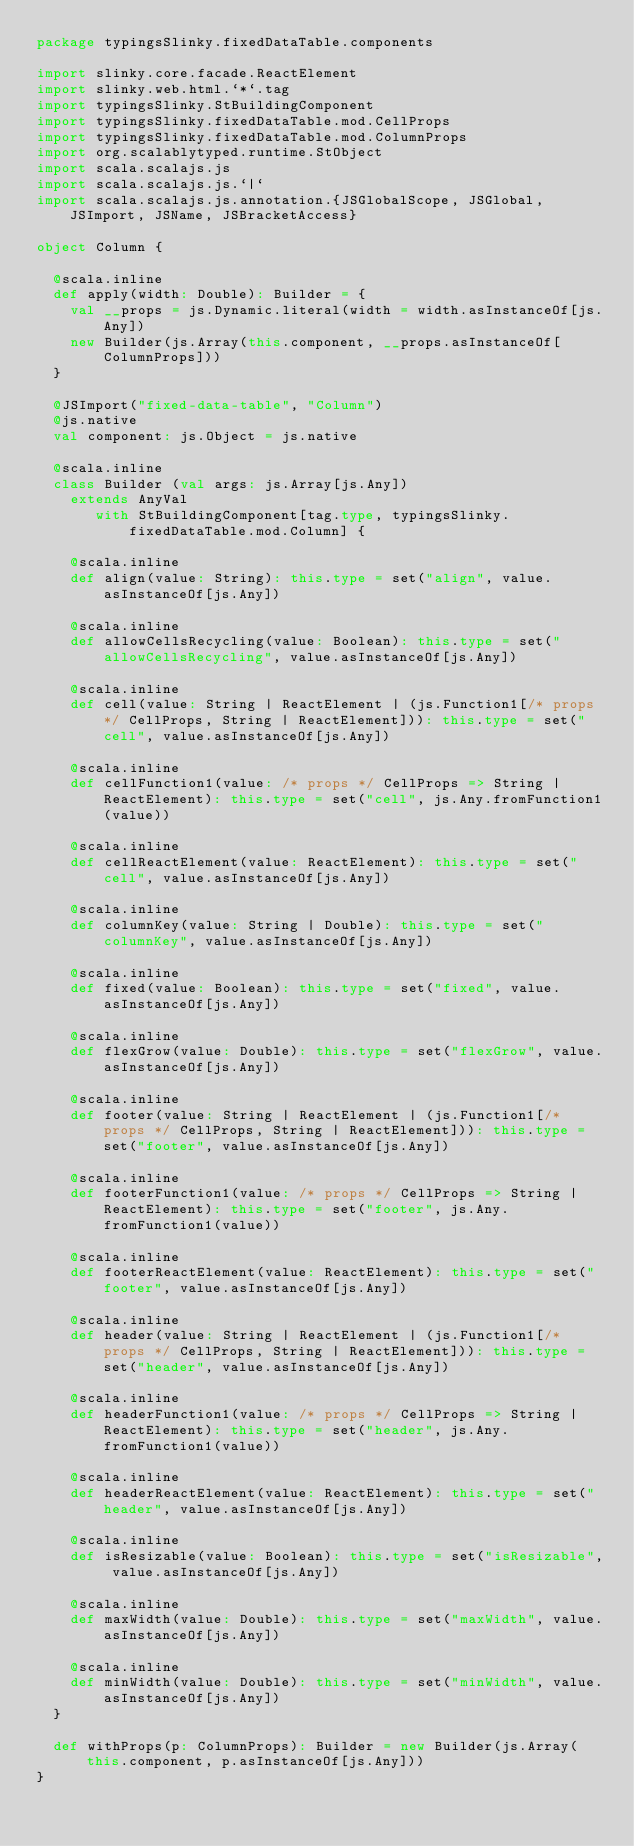<code> <loc_0><loc_0><loc_500><loc_500><_Scala_>package typingsSlinky.fixedDataTable.components

import slinky.core.facade.ReactElement
import slinky.web.html.`*`.tag
import typingsSlinky.StBuildingComponent
import typingsSlinky.fixedDataTable.mod.CellProps
import typingsSlinky.fixedDataTable.mod.ColumnProps
import org.scalablytyped.runtime.StObject
import scala.scalajs.js
import scala.scalajs.js.`|`
import scala.scalajs.js.annotation.{JSGlobalScope, JSGlobal, JSImport, JSName, JSBracketAccess}

object Column {
  
  @scala.inline
  def apply(width: Double): Builder = {
    val __props = js.Dynamic.literal(width = width.asInstanceOf[js.Any])
    new Builder(js.Array(this.component, __props.asInstanceOf[ColumnProps]))
  }
  
  @JSImport("fixed-data-table", "Column")
  @js.native
  val component: js.Object = js.native
  
  @scala.inline
  class Builder (val args: js.Array[js.Any])
    extends AnyVal
       with StBuildingComponent[tag.type, typingsSlinky.fixedDataTable.mod.Column] {
    
    @scala.inline
    def align(value: String): this.type = set("align", value.asInstanceOf[js.Any])
    
    @scala.inline
    def allowCellsRecycling(value: Boolean): this.type = set("allowCellsRecycling", value.asInstanceOf[js.Any])
    
    @scala.inline
    def cell(value: String | ReactElement | (js.Function1[/* props */ CellProps, String | ReactElement])): this.type = set("cell", value.asInstanceOf[js.Any])
    
    @scala.inline
    def cellFunction1(value: /* props */ CellProps => String | ReactElement): this.type = set("cell", js.Any.fromFunction1(value))
    
    @scala.inline
    def cellReactElement(value: ReactElement): this.type = set("cell", value.asInstanceOf[js.Any])
    
    @scala.inline
    def columnKey(value: String | Double): this.type = set("columnKey", value.asInstanceOf[js.Any])
    
    @scala.inline
    def fixed(value: Boolean): this.type = set("fixed", value.asInstanceOf[js.Any])
    
    @scala.inline
    def flexGrow(value: Double): this.type = set("flexGrow", value.asInstanceOf[js.Any])
    
    @scala.inline
    def footer(value: String | ReactElement | (js.Function1[/* props */ CellProps, String | ReactElement])): this.type = set("footer", value.asInstanceOf[js.Any])
    
    @scala.inline
    def footerFunction1(value: /* props */ CellProps => String | ReactElement): this.type = set("footer", js.Any.fromFunction1(value))
    
    @scala.inline
    def footerReactElement(value: ReactElement): this.type = set("footer", value.asInstanceOf[js.Any])
    
    @scala.inline
    def header(value: String | ReactElement | (js.Function1[/* props */ CellProps, String | ReactElement])): this.type = set("header", value.asInstanceOf[js.Any])
    
    @scala.inline
    def headerFunction1(value: /* props */ CellProps => String | ReactElement): this.type = set("header", js.Any.fromFunction1(value))
    
    @scala.inline
    def headerReactElement(value: ReactElement): this.type = set("header", value.asInstanceOf[js.Any])
    
    @scala.inline
    def isResizable(value: Boolean): this.type = set("isResizable", value.asInstanceOf[js.Any])
    
    @scala.inline
    def maxWidth(value: Double): this.type = set("maxWidth", value.asInstanceOf[js.Any])
    
    @scala.inline
    def minWidth(value: Double): this.type = set("minWidth", value.asInstanceOf[js.Any])
  }
  
  def withProps(p: ColumnProps): Builder = new Builder(js.Array(this.component, p.asInstanceOf[js.Any]))
}
</code> 